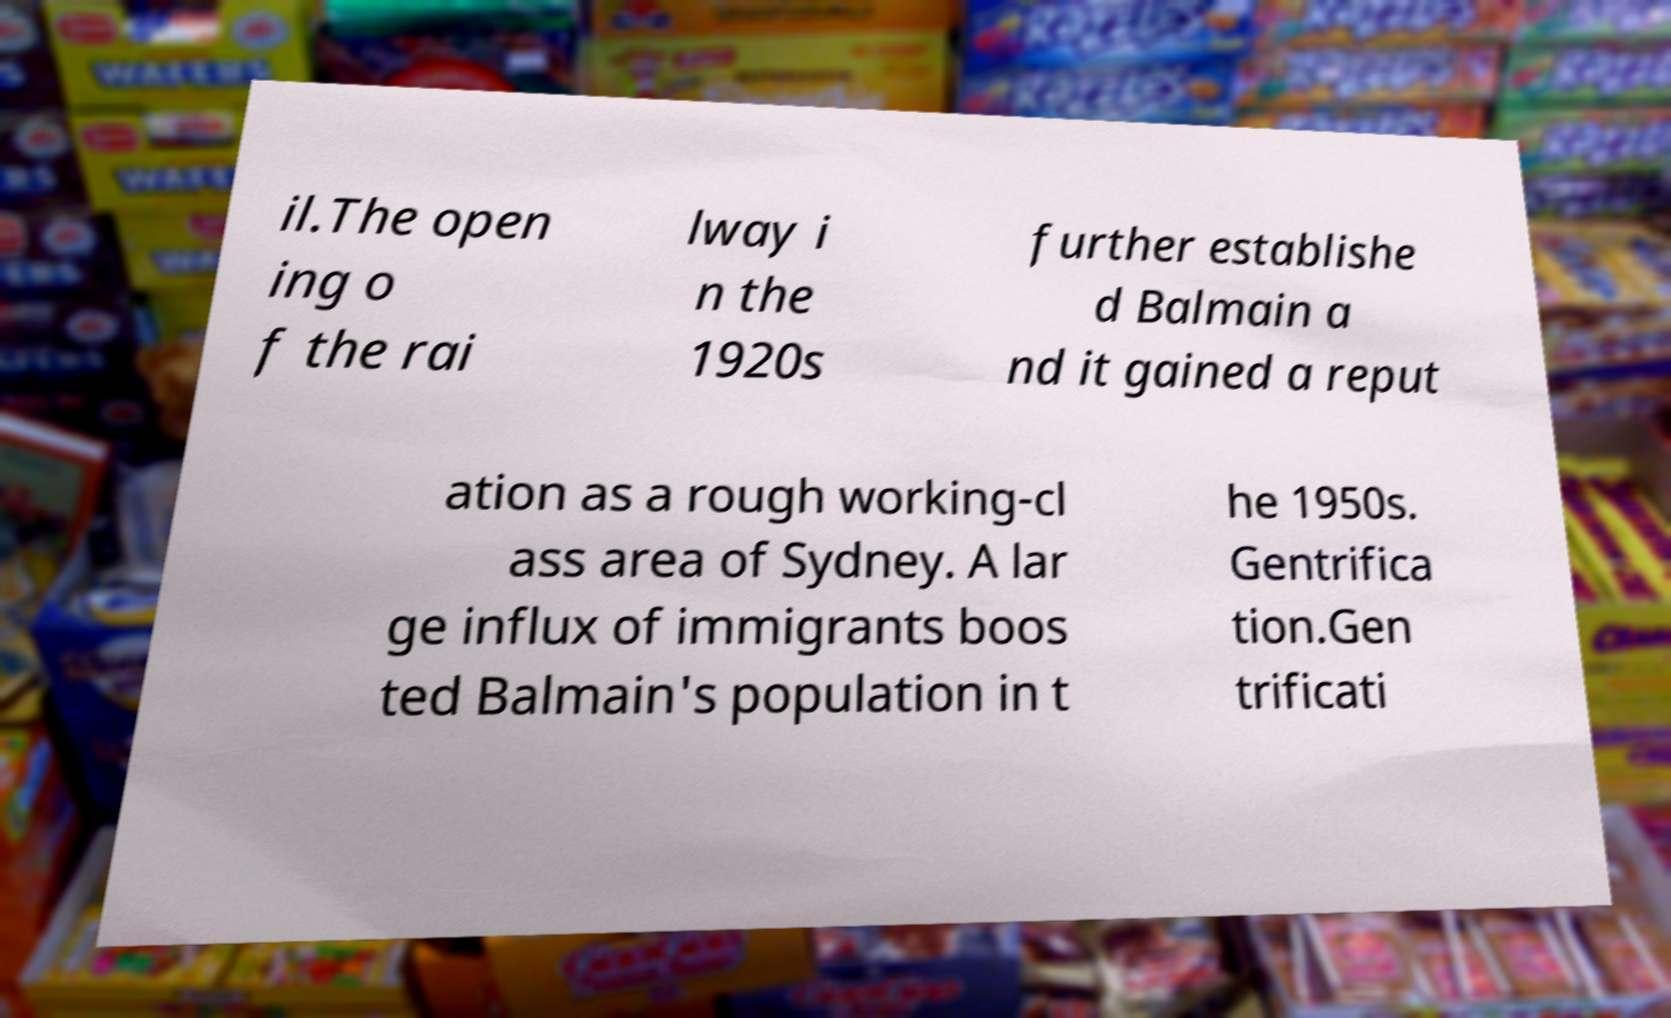I need the written content from this picture converted into text. Can you do that? il.The open ing o f the rai lway i n the 1920s further establishe d Balmain a nd it gained a reput ation as a rough working-cl ass area of Sydney. A lar ge influx of immigrants boos ted Balmain's population in t he 1950s. Gentrifica tion.Gen trificati 